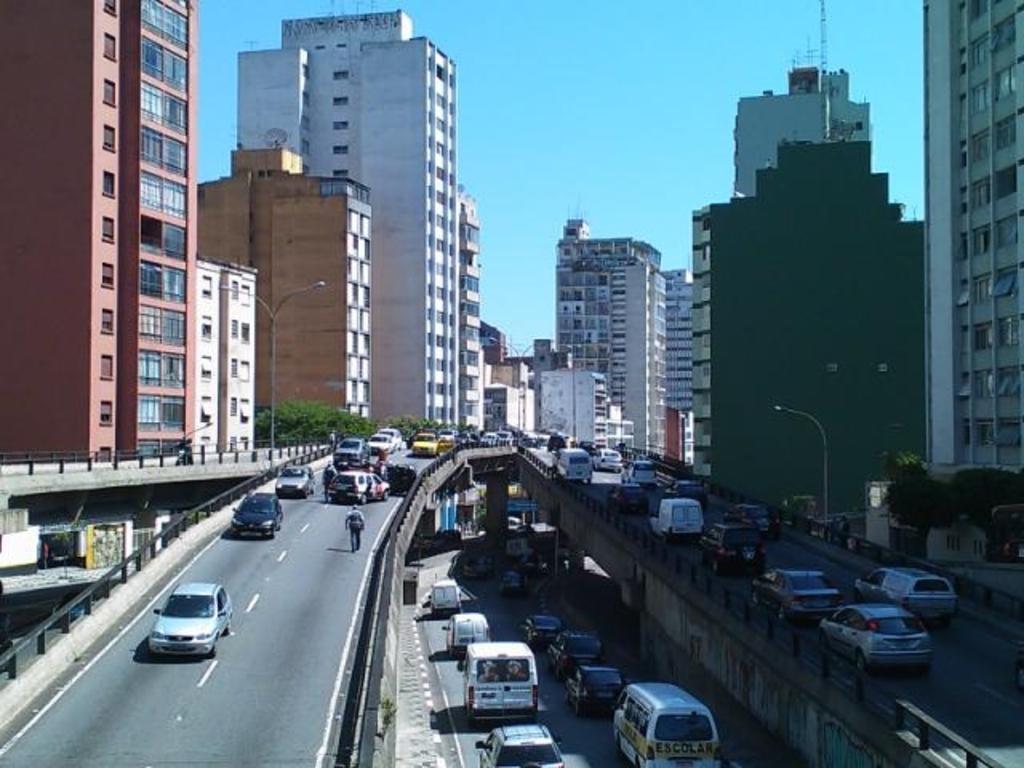Describe this image in one or two sentences. This image consists of many buildings on the roads. On the left and right, there are buildings. At the top, there is sky. 